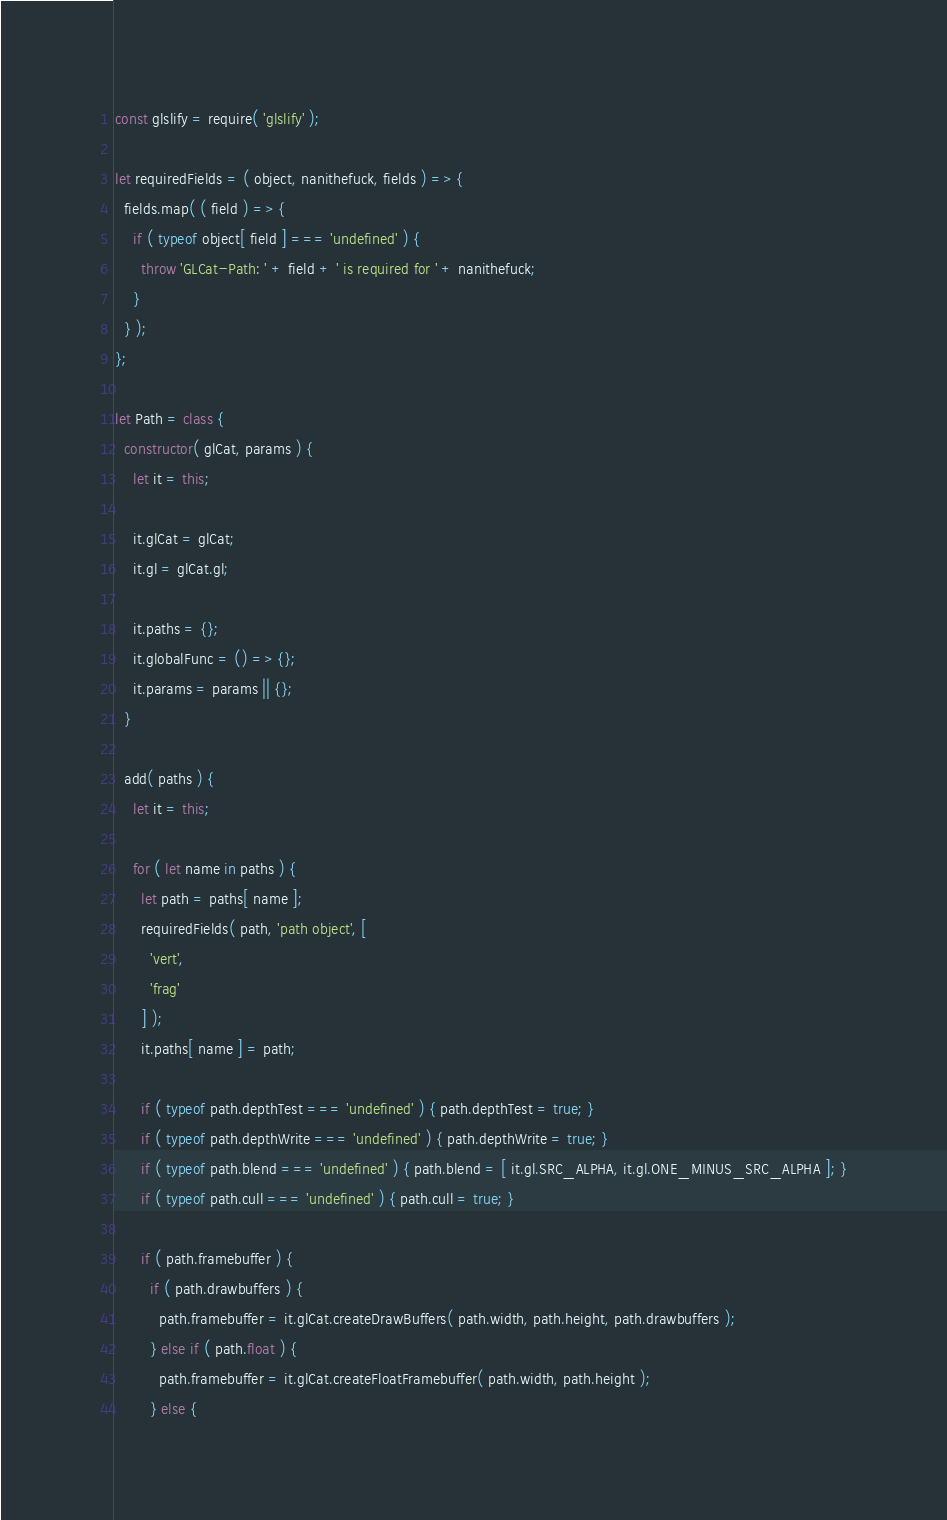Convert code to text. <code><loc_0><loc_0><loc_500><loc_500><_JavaScript_>const glslify = require( 'glslify' );

let requiredFields = ( object, nanithefuck, fields ) => {
  fields.map( ( field ) => {
    if ( typeof object[ field ] === 'undefined' ) {
      throw 'GLCat-Path: ' + field + ' is required for ' + nanithefuck;
    }
  } );
};

let Path = class {
  constructor( glCat, params ) {
    let it = this;

    it.glCat = glCat;
    it.gl = glCat.gl;

    it.paths = {};
    it.globalFunc = () => {};
    it.params = params || {};
  }

  add( paths ) {
    let it = this;

    for ( let name in paths ) {
      let path = paths[ name ];
      requiredFields( path, 'path object', [
        'vert',
        'frag'
      ] );
      it.paths[ name ] = path;

      if ( typeof path.depthTest === 'undefined' ) { path.depthTest = true; }
      if ( typeof path.depthWrite === 'undefined' ) { path.depthWrite = true; }
      if ( typeof path.blend === 'undefined' ) { path.blend = [ it.gl.SRC_ALPHA, it.gl.ONE_MINUS_SRC_ALPHA ]; }
      if ( typeof path.cull === 'undefined' ) { path.cull = true; }

      if ( path.framebuffer ) {
        if ( path.drawbuffers ) {
          path.framebuffer = it.glCat.createDrawBuffers( path.width, path.height, path.drawbuffers );
        } else if ( path.float ) {
          path.framebuffer = it.glCat.createFloatFramebuffer( path.width, path.height );
        } else {</code> 